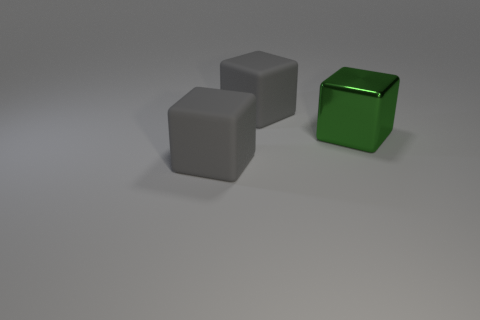Add 3 metal things. How many objects exist? 6 Add 1 small purple metal cylinders. How many small purple metal cylinders exist? 1 Subtract 0 purple cubes. How many objects are left? 3 Subtract all big shiny cubes. Subtract all tiny green shiny balls. How many objects are left? 2 Add 1 big rubber cubes. How many big rubber cubes are left? 3 